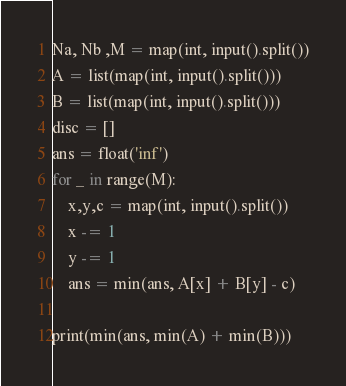<code> <loc_0><loc_0><loc_500><loc_500><_Python_>Na, Nb ,M = map(int, input().split())
A = list(map(int, input().split()))
B = list(map(int, input().split()))
disc = []
ans = float('inf')
for _ in range(M):
    x,y,c = map(int, input().split())
    x -= 1
    y -= 1
    ans = min(ans, A[x] + B[y] - c)

print(min(ans, min(A) + min(B)))


</code> 